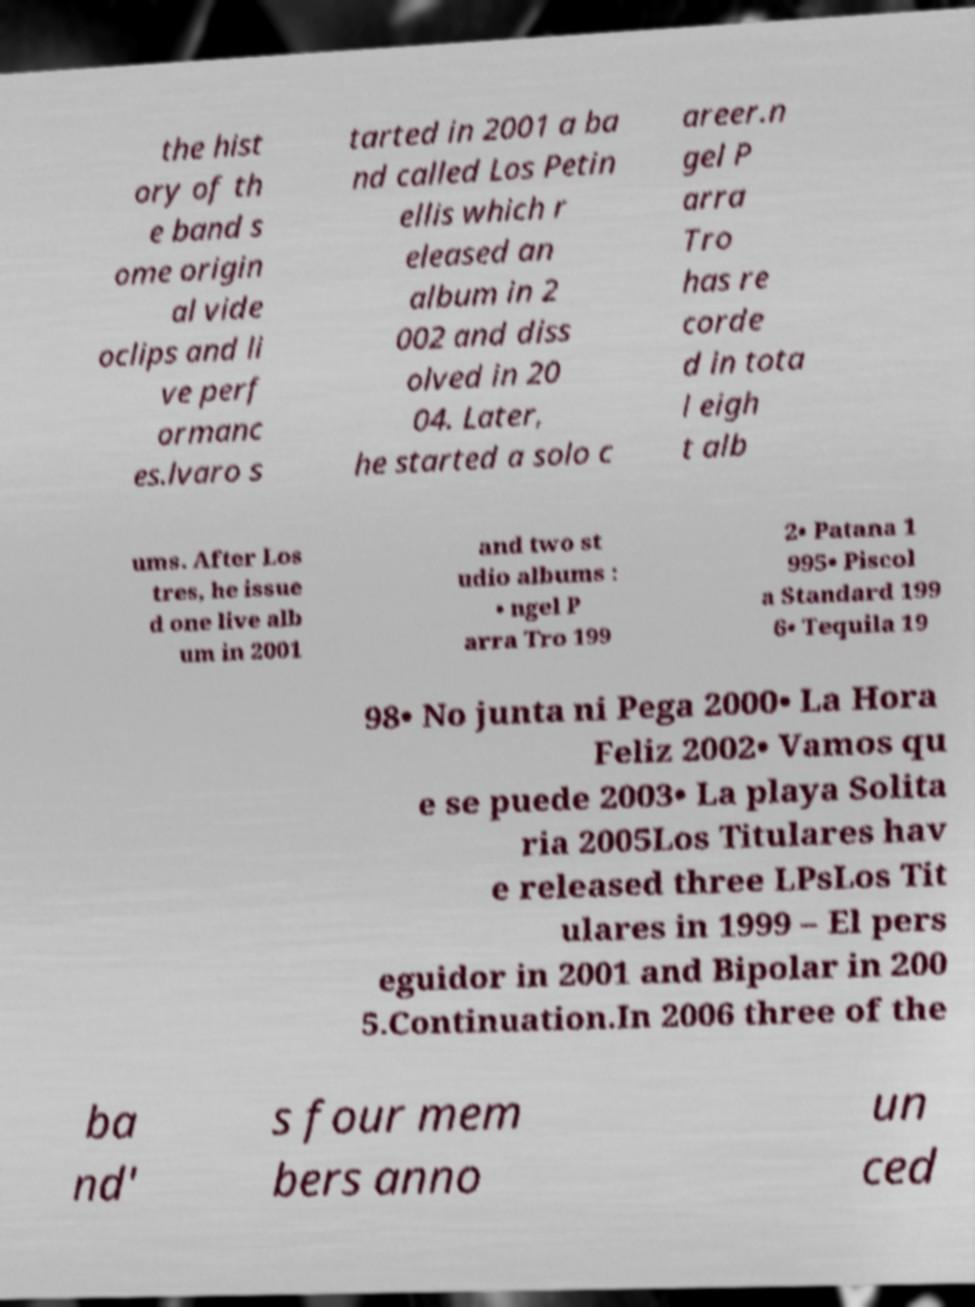Can you accurately transcribe the text from the provided image for me? the hist ory of th e band s ome origin al vide oclips and li ve perf ormanc es.lvaro s tarted in 2001 a ba nd called Los Petin ellis which r eleased an album in 2 002 and diss olved in 20 04. Later, he started a solo c areer.n gel P arra Tro has re corde d in tota l eigh t alb ums. After Los tres, he issue d one live alb um in 2001 and two st udio albums : • ngel P arra Tro 199 2• Patana 1 995• Piscol a Standard 199 6• Tequila 19 98• No junta ni Pega 2000• La Hora Feliz 2002• Vamos qu e se puede 2003• La playa Solita ria 2005Los Titulares hav e released three LPsLos Tit ulares in 1999 – El pers eguidor in 2001 and Bipolar in 200 5.Continuation.In 2006 three of the ba nd' s four mem bers anno un ced 